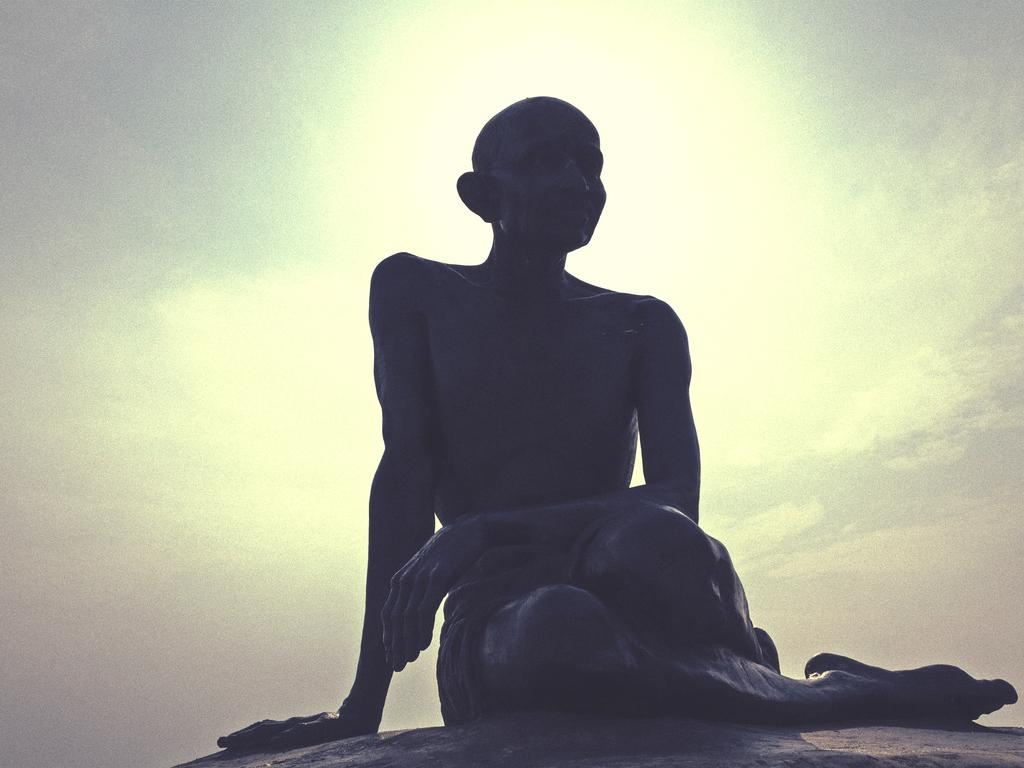What is the main subject of the image? There is a statue in the image. What can be seen in the background of the image? The sky is visible in the background of the image. Can you describe the curve of the wood used to make the woman in the image? There is no woman or wood present in the image; it features a statue and the sky in the background. 